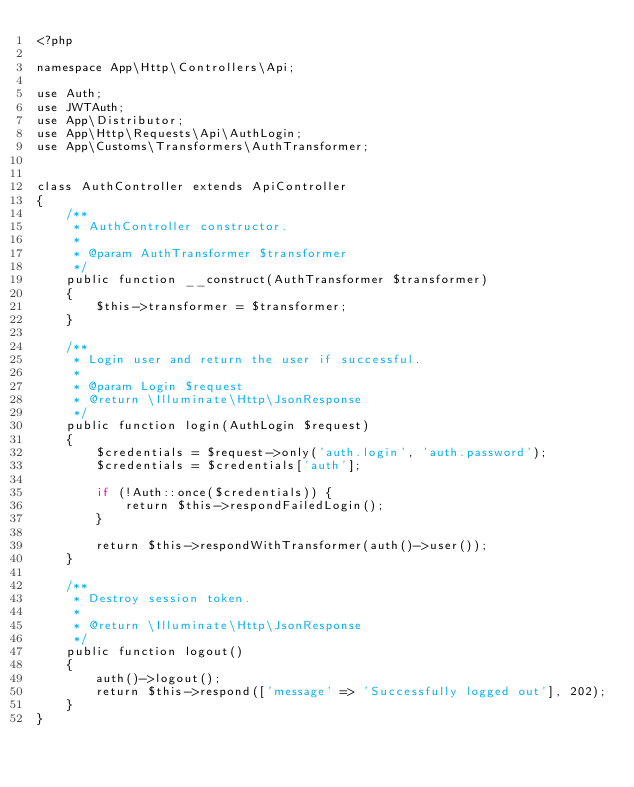Convert code to text. <code><loc_0><loc_0><loc_500><loc_500><_PHP_><?php

namespace App\Http\Controllers\Api;

use Auth;
use JWTAuth;
use App\Distributor;
use App\Http\Requests\Api\AuthLogin;
use App\Customs\Transformers\AuthTransformer;


class AuthController extends ApiController
{
    /**
     * AuthController constructor.
     *
     * @param AuthTransformer $transformer
     */
    public function __construct(AuthTransformer $transformer)
    {
        $this->transformer = $transformer;
    }

    /**
     * Login user and return the user if successful.
     *
     * @param Login $request
     * @return \Illuminate\Http\JsonResponse
     */
    public function login(AuthLogin $request)
    {
        $credentials = $request->only('auth.login', 'auth.password');
        $credentials = $credentials['auth'];

        if (!Auth::once($credentials)) {
            return $this->respondFailedLogin();
        }

        return $this->respondWithTransformer(auth()->user());
    }

    /**
     * Destroy session token.
     * 
     * @return \Illuminate\Http\JsonResponse
     */
    public function logout()
    {
        auth()->logout();
        return $this->respond(['message' => 'Successfully logged out'], 202);
    }
}</code> 